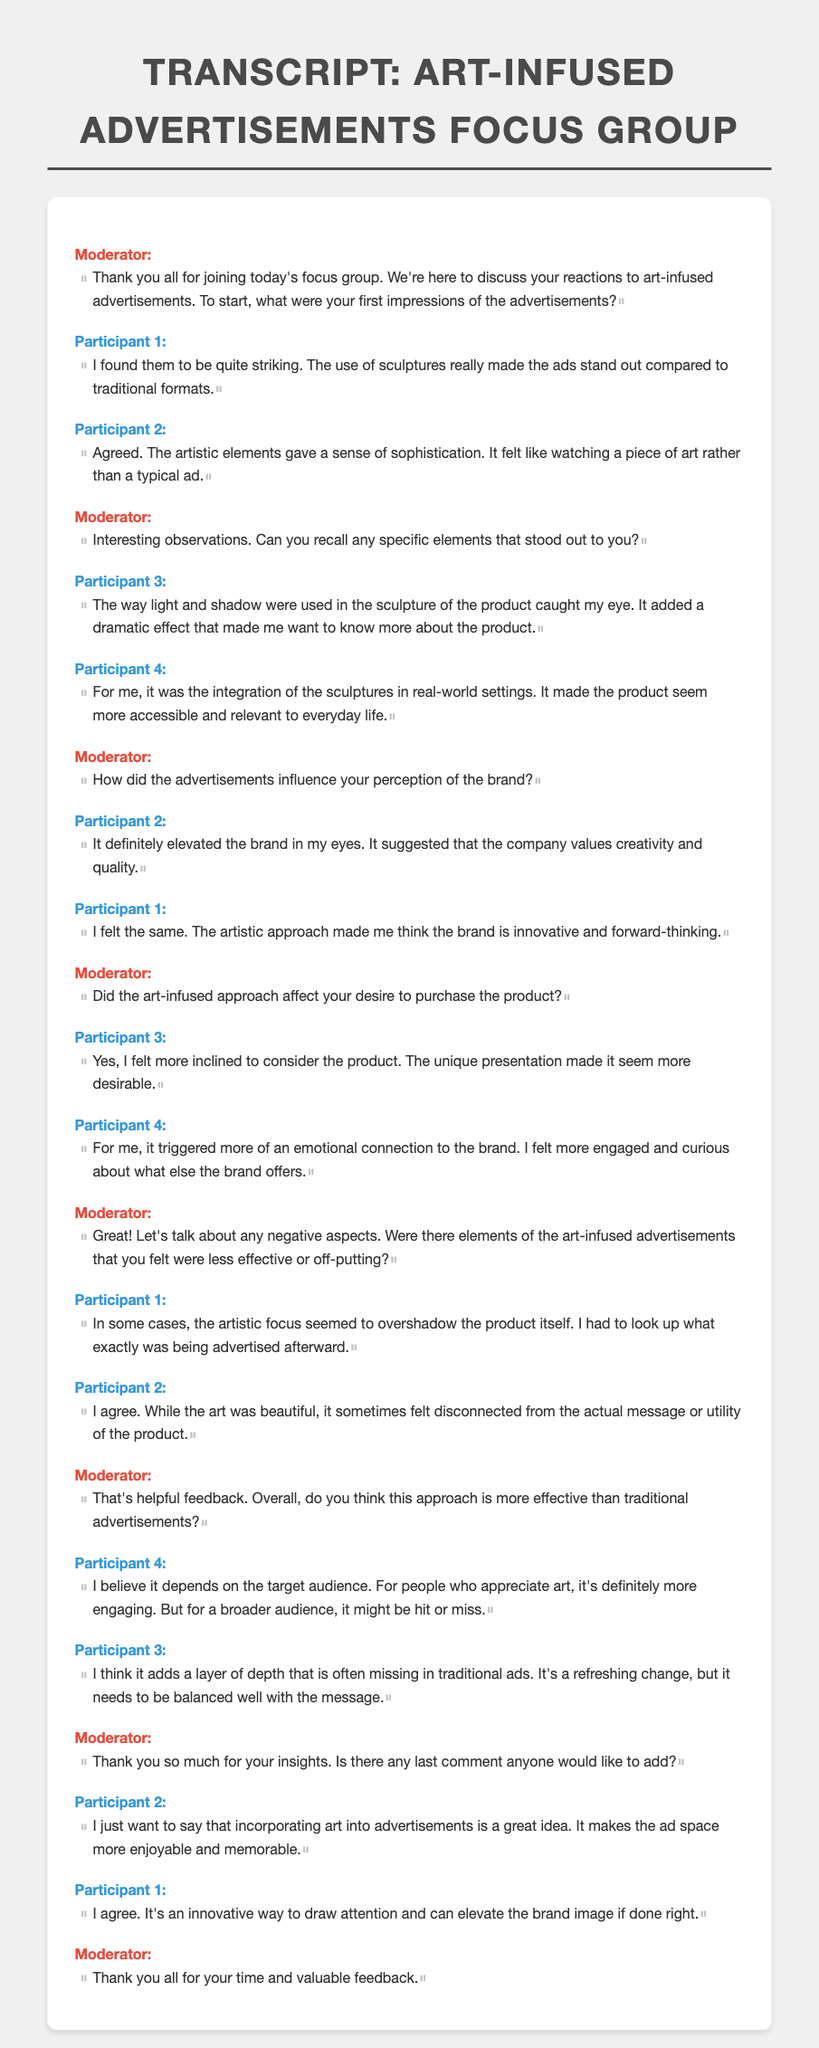What were the participants' first impressions of the advertisements? Participant 1 found them to be quite striking, and Participant 2 agreed, stating the artistic elements gave a sense of sophistication.
Answer: Striking and sophisticated What specific element did Participant 3 recall that caught their eye? Participant 3 mentioned the way light and shadow were used in the sculpture of the product, adding a dramatic effect.
Answer: Light and shadow How did the art-infused advertisements influence Participant 2's perception of the brand? Participant 2 felt it elevated the brand, suggesting that the company values creativity and quality.
Answer: Elevated the brand What emotional response did Participant 4 have towards the brand after seeing the advertisements? Participant 4 felt more engaged and curious about what else the brand offers due to an emotional connection triggered by the ads.
Answer: More engaged and curious What negative aspect did Participant 1 note regarding the art-infused focus? Participant 1 felt the artistic focus sometimes overshadowed the product itself, requiring them to look up what was being advertised.
Answer: Artistic focus overshadowed the product What did Participant 4 conclude about the effectiveness of art-infused advertisements compared to traditional ones? Participant 4 believed it depends on the target audience, stating it's more engaging for those who appreciate art but may not resonate with a broader audience.
Answer: Depends on the target audience Did any participant express a positive opinion about incorporating art into advertisements? Participant 2 stated that incorporating art into advertisements is a great idea, making the ad space more enjoyable and memorable.
Answer: Great idea Which participant emphasized the need for balance in the message of art-infused advertisements? Participant 3 emphasized the need for balance, stating that it adds a refreshing change but needs to be balanced well with the message.
Answer: Participant 3 How many participants expressed that the art made them feel more inclined to consider the product? Two participants expressed that they felt more inclined to consider the product due to its unique presentation.
Answer: Two participants 